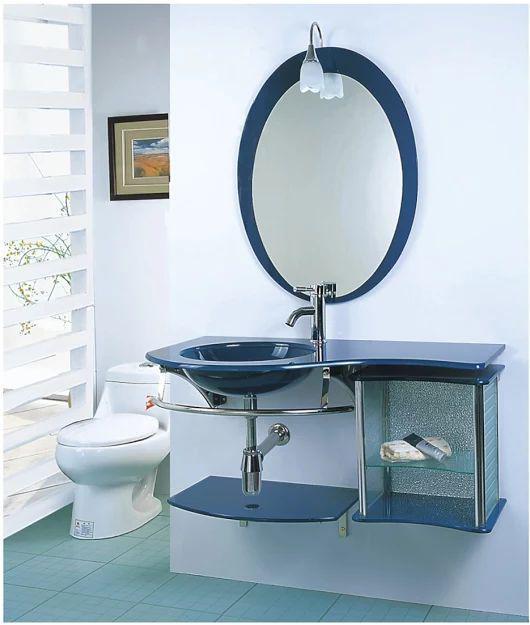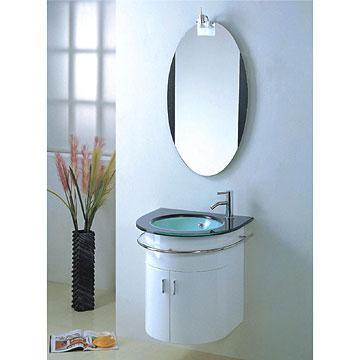The first image is the image on the left, the second image is the image on the right. Analyze the images presented: Is the assertion "There is a frame on the wall in the image on the left." valid? Answer yes or no. Yes. The first image is the image on the left, the second image is the image on the right. For the images displayed, is the sentence "Neither picture contains a mirror that is shaped like a circle or an oval." factually correct? Answer yes or no. No. 